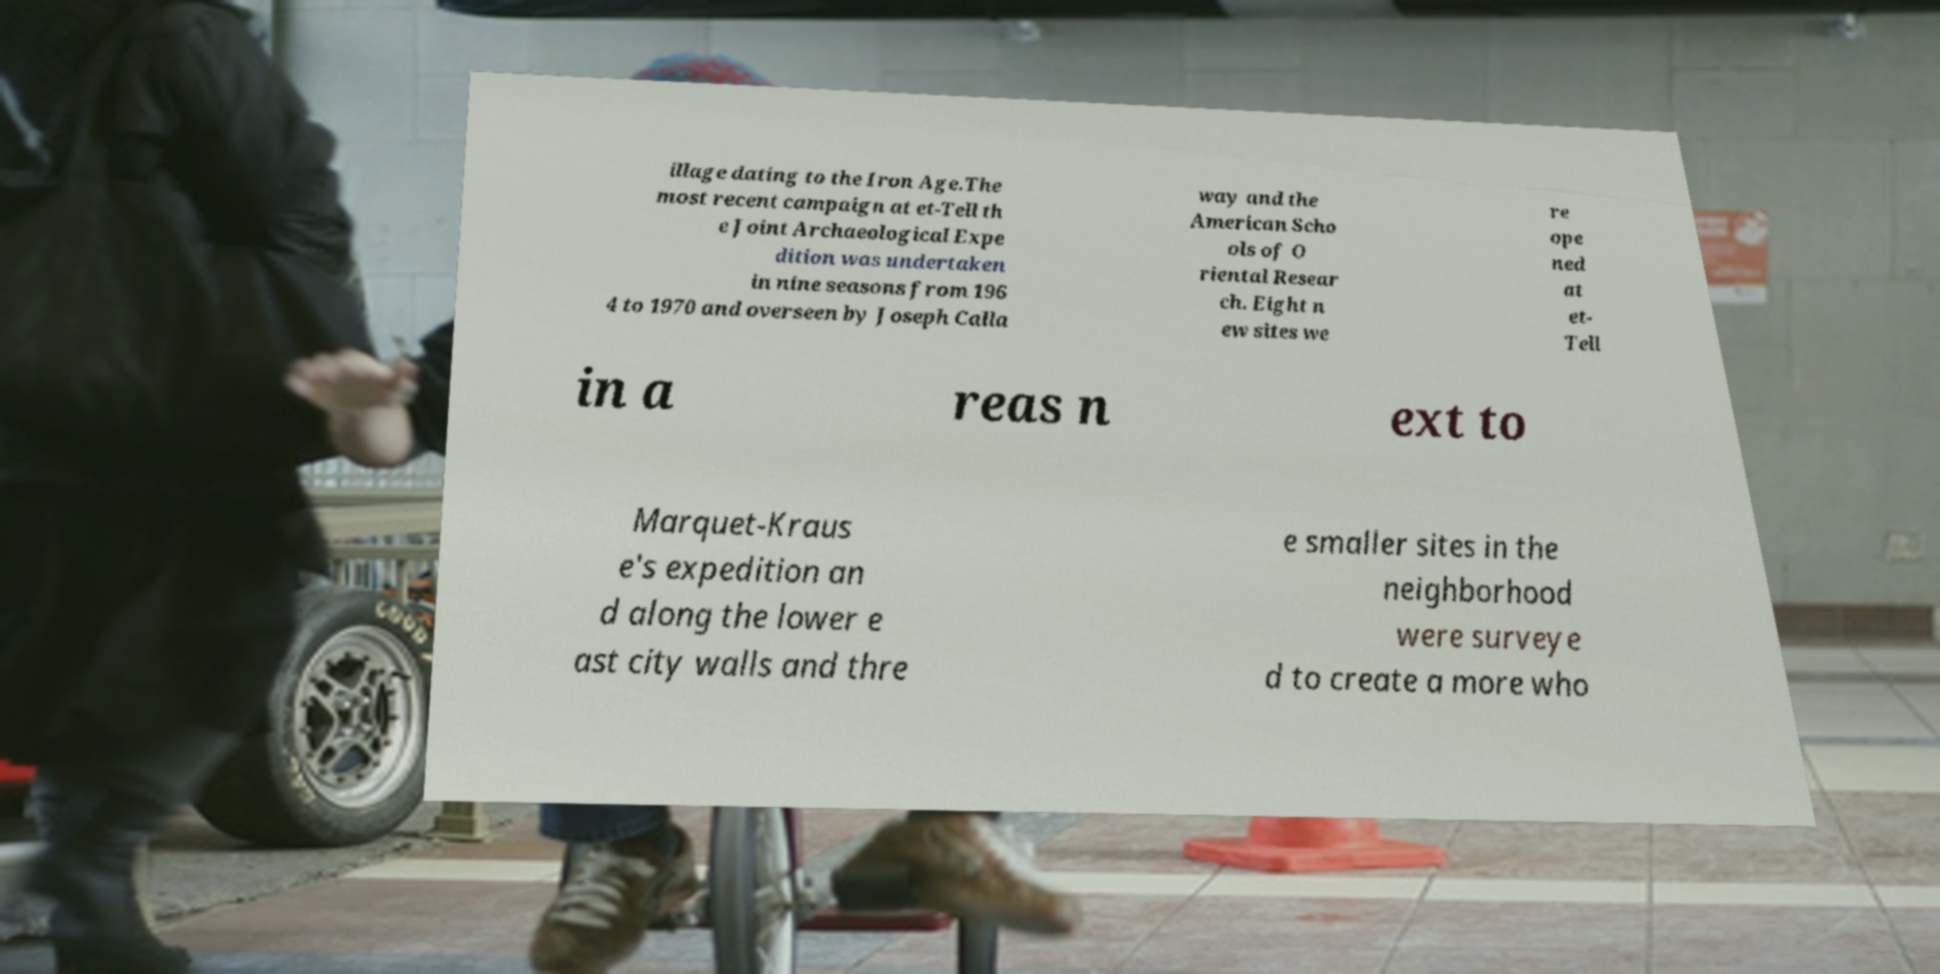Could you extract and type out the text from this image? illage dating to the Iron Age.The most recent campaign at et-Tell th e Joint Archaeological Expe dition was undertaken in nine seasons from 196 4 to 1970 and overseen by Joseph Calla way and the American Scho ols of O riental Resear ch. Eight n ew sites we re ope ned at et- Tell in a reas n ext to Marquet-Kraus e's expedition an d along the lower e ast city walls and thre e smaller sites in the neighborhood were surveye d to create a more who 